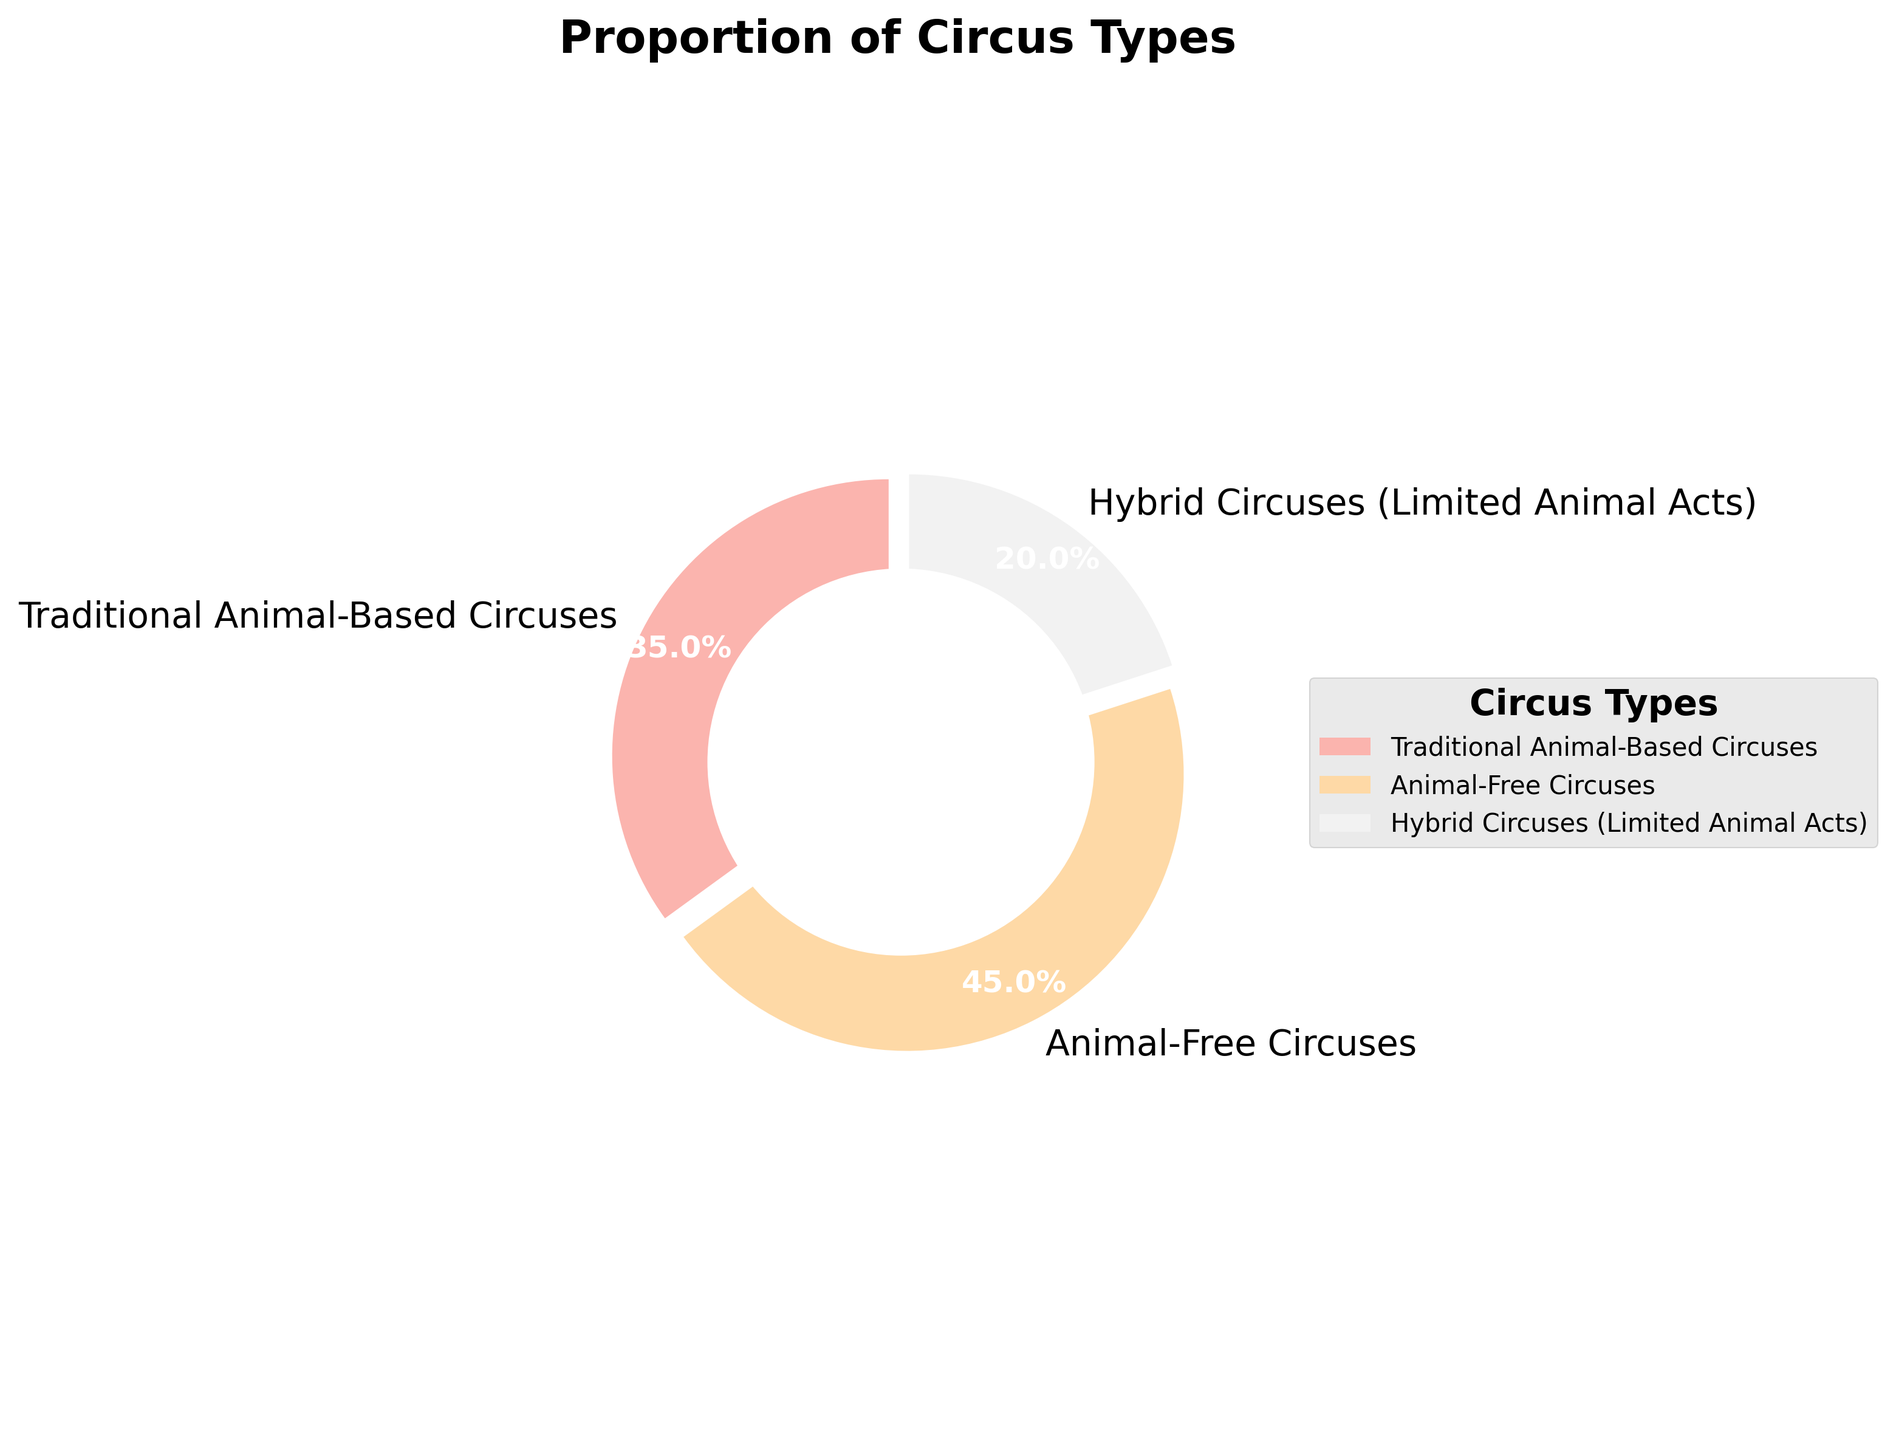Which type of circus is the most common? The pie chart shows that Animal-Free Circuses have the largest proportion with a percentage of 45%.
Answer: Animal-Free Circuses What percentage of circuses include some form of animal act (whether traditional or limited)? The pie chart shows that Traditional Animal-Based Circuses account for 35% and Hybrid Circuses for 20%. Adding these together gives 35% + 20% = 55%.
Answer: 55% Which type of circus is the least common? The pie chart shows that Hybrid Circuses (Limited Animal Acts) have the smallest proportion at 20%.
Answer: Hybrid Circuses (Limited Animal Acts) Is the proportion of animal-free circuses greater than the combination of hybrid and traditional animal-based circuses? The pie chart shows that Animal-Free Circuses account for 45%, while the combined proportion of Hybrid and Traditional Animal-Based Circuses is 35% + 20% = 55%. Since 45% is not greater than 55%, the answer is no.
Answer: No How much greater is the proportion of animal-free circuses compared to traditional animal-based circuses? The pie chart indicates Animal-Free Circuses are at 45% and Traditional Animal-Based Circuses at 35%. The difference is 45% - 35% = 10%.
Answer: 10% What is the total percentage of circuses that use animals in some capacity? Traditional Animal-Based Circuses account for 35% and Hybrid Circuses account for 20%. The total percentage is 35% + 20% = 55%.
Answer: 55% What color is used to represent Hybrid Circuses (Limited Animal Acts)? The pie chart uses a color scheme where each segment is distinctly colored. The color for Hybrid Circuses is typically the third slice from the start angle.
Answer: (Answer depends on the actual color used in rendering, let's assume it's blue: Blue) Which category falls into the middle range in terms of percentage? The pie chart shows three categories with percentages: Animal-Free Circuses (45%), Traditional Animal-Based Circuses (35%), and Hybrid Circuses (20%). The middle range percentage is 35% for Traditional Animal-Based Circuses.
Answer: Traditional Animal-Based Circuses Would combining the animal-free and hybrid categories result in a majority of the circuses? Animal-Free Circuses have 45% and Hybrid Circuses have 20%. Combined, they account for 45% + 20% = 65%, which is a majority.
Answer: Yes What fraction of circuses are traditional animal-based circuses? Traditional Animal-Based Circuses account for 35%. To convert this to a fraction: 35% is equivalent to 35/100, which simplifies to 7/20.
Answer: 7/20 